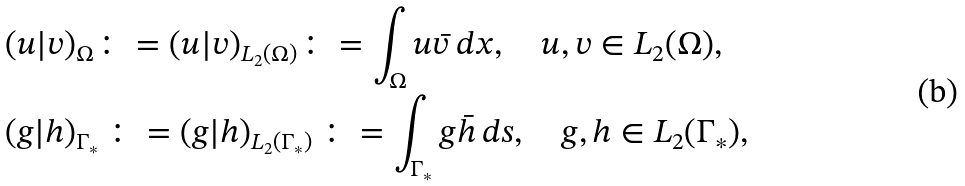<formula> <loc_0><loc_0><loc_500><loc_500>& ( u | v ) _ { \Omega } \colon = ( u | v ) _ { L _ { 2 } ( \Omega ) } \colon = \int _ { \Omega } u \bar { v } \, d x , \quad u , v \in L _ { 2 } ( \Omega ) , \\ & ( g | h ) _ { \Gamma _ { * } } \, \colon = ( g | h ) _ { L _ { 2 } ( \Gamma _ { * } ) } \, \colon = \int _ { \Gamma _ { * } } g \bar { h } \, d s , \quad g , h \in L _ { 2 } ( \Gamma _ { * } ) ,</formula> 